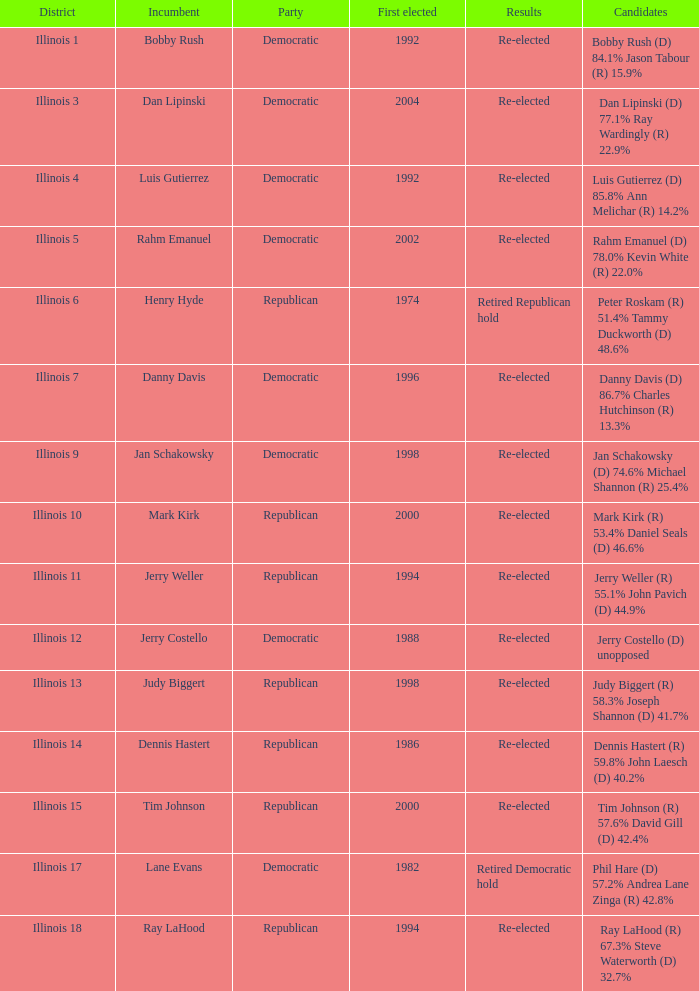Who were the nominees when the first elected was a republican in 1998? Judy Biggert (R) 58.3% Joseph Shannon (D) 41.7%. 